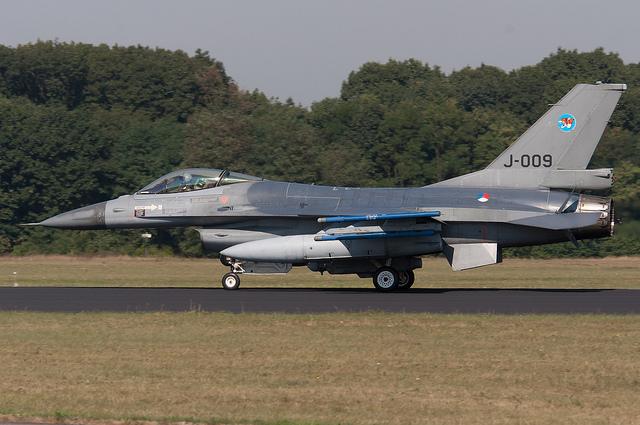Is the number painted on the plane an even or odd number?
Keep it brief. Odd. What number is on the plane?
Short answer required. 009. Is there a website address on the airplane?
Quick response, please. No. Is the jet running?
Quick response, please. Yes. What is green?
Answer briefly. Trees. What characters are pointed on the tail fin?
Keep it brief. J-009. What is the jet's number?
Concise answer only. J-009. Is this a passenger aircraft?
Keep it brief. No. 